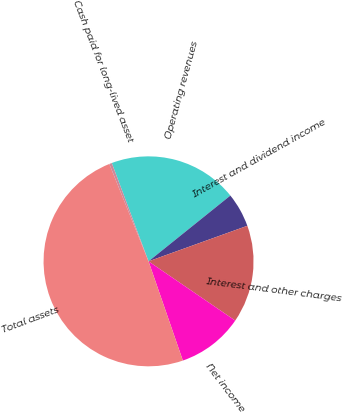<chart> <loc_0><loc_0><loc_500><loc_500><pie_chart><fcel>Operating revenues<fcel>Interest and dividend income<fcel>Interest and other charges<fcel>Net income<fcel>Total assets<fcel>Cash paid for long-lived asset<nl><fcel>19.92%<fcel>5.28%<fcel>15.04%<fcel>10.16%<fcel>49.21%<fcel>0.4%<nl></chart> 